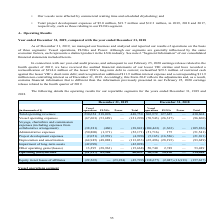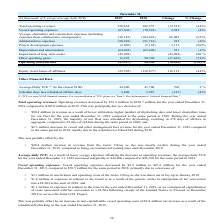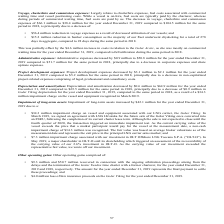According to Golar Lng's financial document, What was the reason for the increase in average daily TCE? Lower voyage expenses offsetting the decrease in operating revenues. The document states: "Average daily TCE: As a result of lower voyage expenses offsetting the decrease in operating revenues, the average daily TCE for the year ended Decemb..." Also, What accounted for the change in administrative expenses? Due to a decrease in corporate expenses and share options expenses.. The document states: "7 million for the same period in 2018, principally due to a decrease in corporate expenses and share options expenses...." Also, In which years was the  average daily TCE recorded for? The document shows two values: 2018 and 2019. From the document: "31, (in thousands of $, except average daily TCE) 2019 2018 Change % Change in thousands of $, except average daily TCE) 2019 2018 Change % Change..." Additionally, In which year was the project development expenses higher? According to the financial document, 2018. The relevant text states: "in thousands of $, except average daily TCE) 2019 2018 Change % Change..." Also, can you calculate: What was the change in the calendar days less scheduled off-hire days? Based on the calculation: 3,987 - 3,840 , the result is 147 (in thousands). This is based on the information: "00 2 % Calendar days less scheduled off-hire days 3,840 3,987 (147) (4)% Calendar days less scheduled off-hire days 3,840 3,987 (147) (4)%..." The key data points involved are: 3,840, 3,987. Also, can you calculate: What was the percentage change in average daily TCE? To answer this question, I need to perform calculations using the financial data. The calculation is: (44,400 - 43,700)/43,700 , which equals 1.6 (percentage). This is based on the information: "verage Daily TCE (1) (to the closest $100) 44,400 43,700 700 2 % Calendar days less scheduled off-hire days 3,840 3,987 (147) (4)% Average Daily TCE (1) (to the closest $100) 44,400 43,700 700 2 % Cal..." The key data points involved are: 43,700, 44,400. 